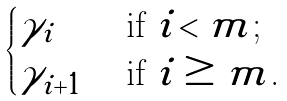<formula> <loc_0><loc_0><loc_500><loc_500>\begin{cases} \gamma _ { i } & \text { if $i < m$;} \\ \gamma _ { i + 1 } & \text { if $i \geq m$.} \end{cases}</formula> 